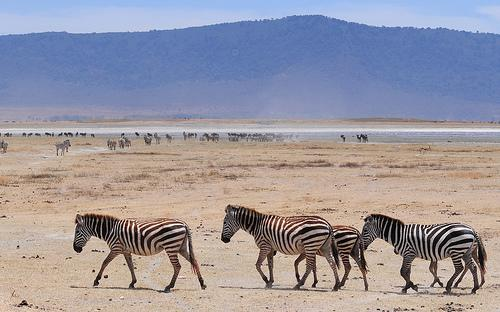Question: when is this photo taken?
Choices:
A. From dusk till dawn.
B. The night the lights went out in Georgia.
C. During the day.
D. During the total eclipse of the heart.
Answer with the letter. Answer: C Question: where are the zebras going?
Choices:
A. To the breeding grounds.
B. To the water.
C. To the feeding grounds.
D. To the zoo.
Answer with the letter. Answer: B Question: how many zebras are at the forefront?
Choices:
A. Four.
B. One.
C. Two.
D. Three.
Answer with the letter. Answer: A Question: why are the zebras going to the water?
Choices:
A. They need a bath.
B. The like to swim.
C. They visit the crocodiles.
D. They are thirsty.
Answer with the letter. Answer: D Question: what are the zebras doing?
Choices:
A. Scratching.
B. Drinking.
C. Galloping.
D. Sleeping.
Answer with the letter. Answer: C 